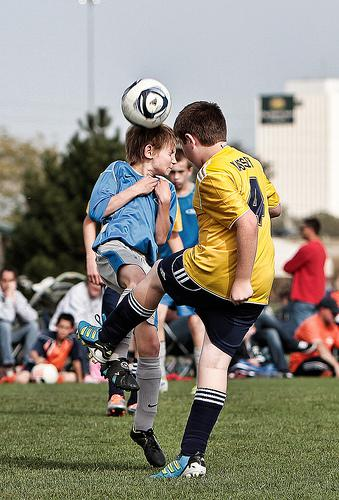Question: how is the day?
Choices:
A. Sunny.
B. Rainy.
C. Cold.
D. Wet.
Answer with the letter. Answer: A Question: where is the shadow?
Choices:
A. On the tree.
B. On the leaves.
C. In the ground.
D. On the flower.
Answer with the letter. Answer: C Question: what are the boys doing?
Choices:
A. Playing.
B. Reading.
C. Talking.
D. Walking.
Answer with the letter. Answer: A Question: what is the color of the ball?
Choices:
A. Red and white.
B. Yellow and white.
C. Blue.
D. Black and white.
Answer with the letter. Answer: D Question: what is the color of the grass?
Choices:
A. Green.
B. Yellow.
C. Brown.
D. Red.
Answer with the letter. Answer: A 